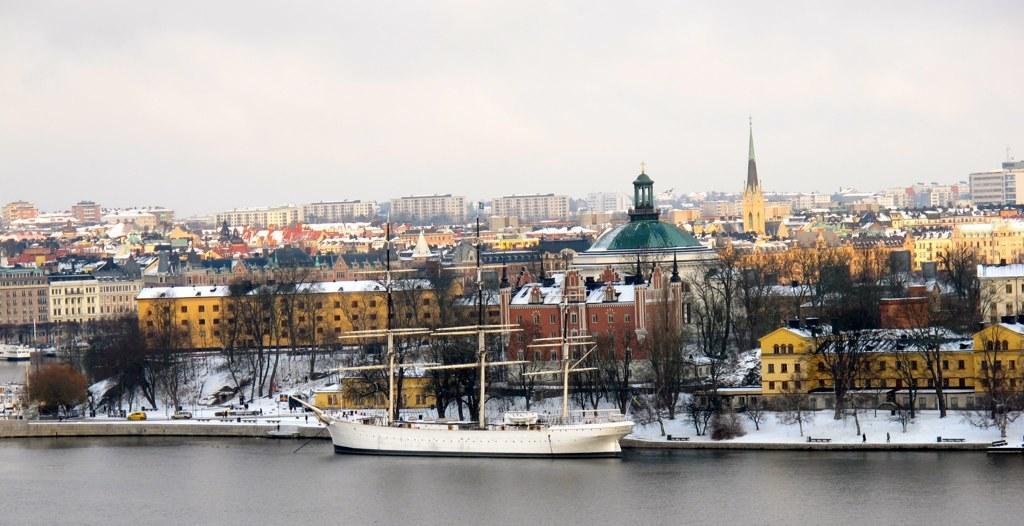Please provide a concise description of this image. In this picture there is water at the bottom side of the image and there are buildings, trees, and cars in the image, there is snow floor in the image. 